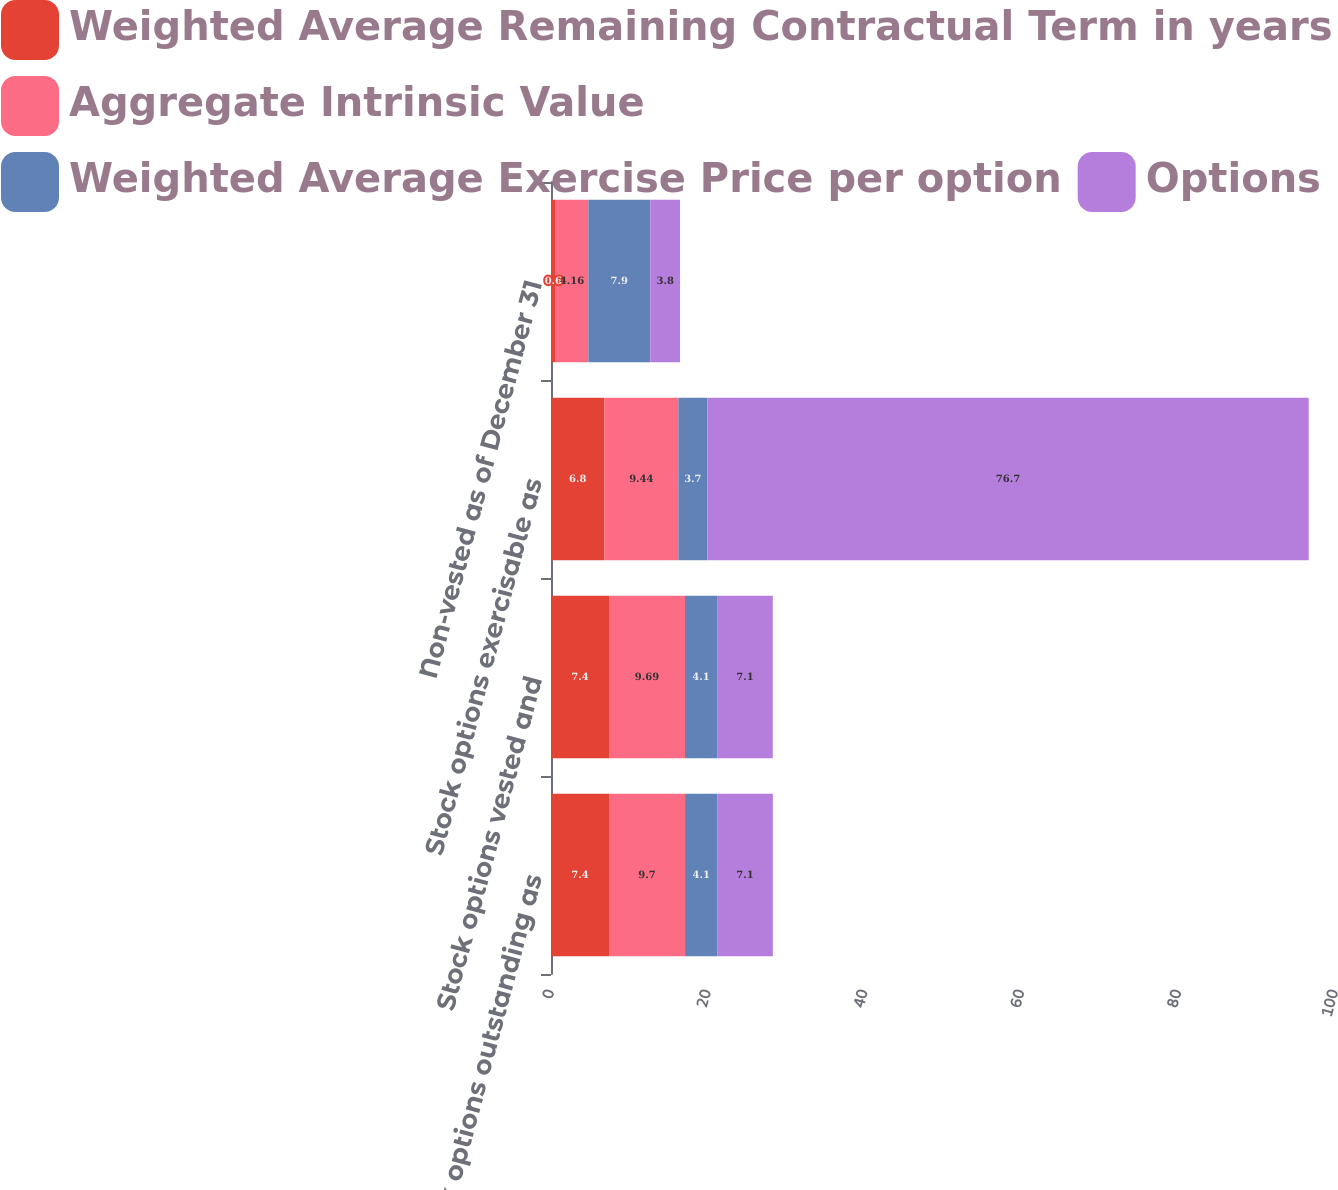Convert chart. <chart><loc_0><loc_0><loc_500><loc_500><stacked_bar_chart><ecel><fcel>Stock options outstanding as<fcel>Stock options vested and<fcel>Stock options exercisable as<fcel>Non-vested as of December 31<nl><fcel>Weighted Average Remaining Contractual Term in years<fcel>7.4<fcel>7.4<fcel>6.8<fcel>0.6<nl><fcel>Aggregate Intrinsic Value<fcel>9.7<fcel>9.69<fcel>9.44<fcel>4.16<nl><fcel>Weighted Average Exercise Price per option<fcel>4.1<fcel>4.1<fcel>3.7<fcel>7.9<nl><fcel>Options<fcel>7.1<fcel>7.1<fcel>76.7<fcel>3.8<nl></chart> 